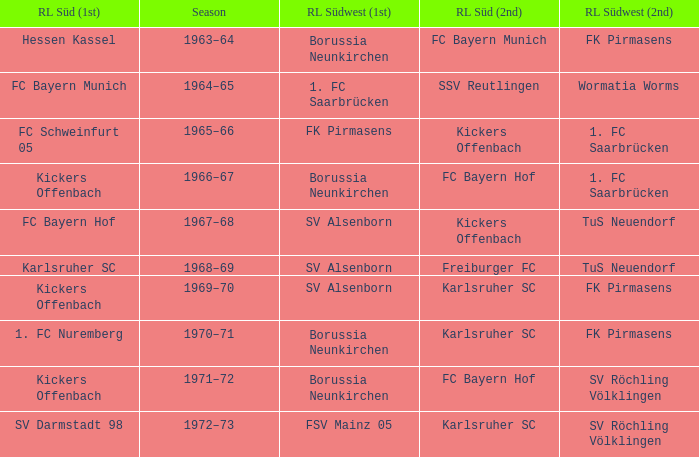Who was RL Süd (1st) when FK Pirmasens was RL Südwest (1st)? FC Schweinfurt 05. 